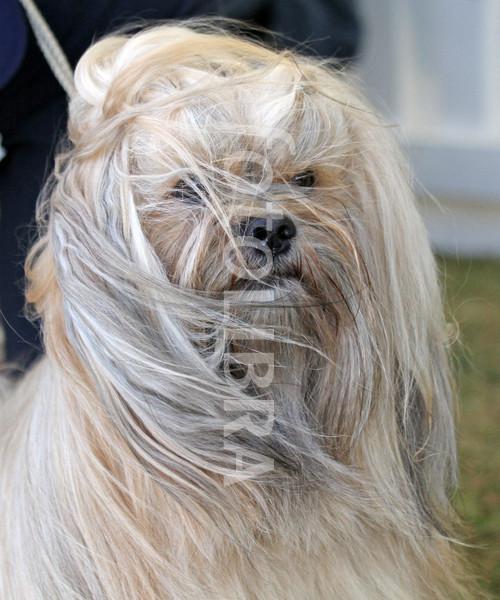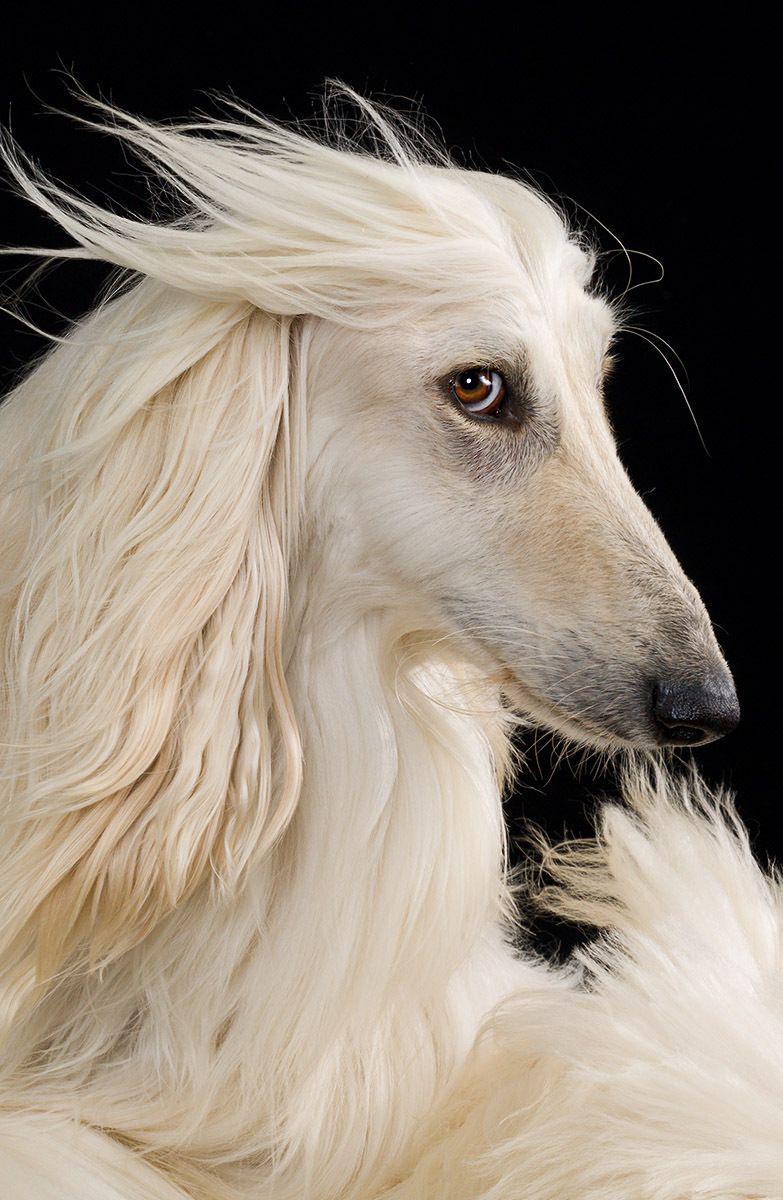The first image is the image on the left, the second image is the image on the right. Assess this claim about the two images: "There are no more than 2 dogs per image pair". Correct or not? Answer yes or no. Yes. 